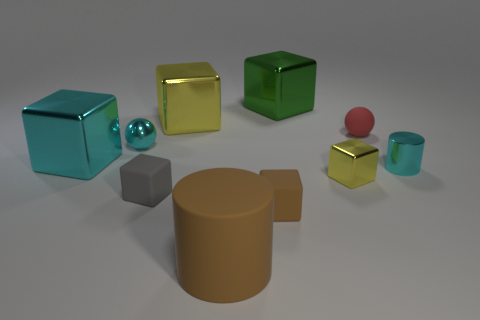Subtract all yellow cylinders. How many yellow blocks are left? 2 Subtract all cyan blocks. How many blocks are left? 5 Subtract all green cubes. How many cubes are left? 5 Subtract all spheres. How many objects are left? 8 Subtract 4 blocks. How many blocks are left? 2 Subtract all blue cubes. Subtract all cyan spheres. How many cubes are left? 6 Add 2 small gray objects. How many small gray objects are left? 3 Add 4 big purple metallic things. How many big purple metallic things exist? 4 Subtract 0 gray spheres. How many objects are left? 10 Subtract all yellow metallic objects. Subtract all cyan metallic cylinders. How many objects are left? 7 